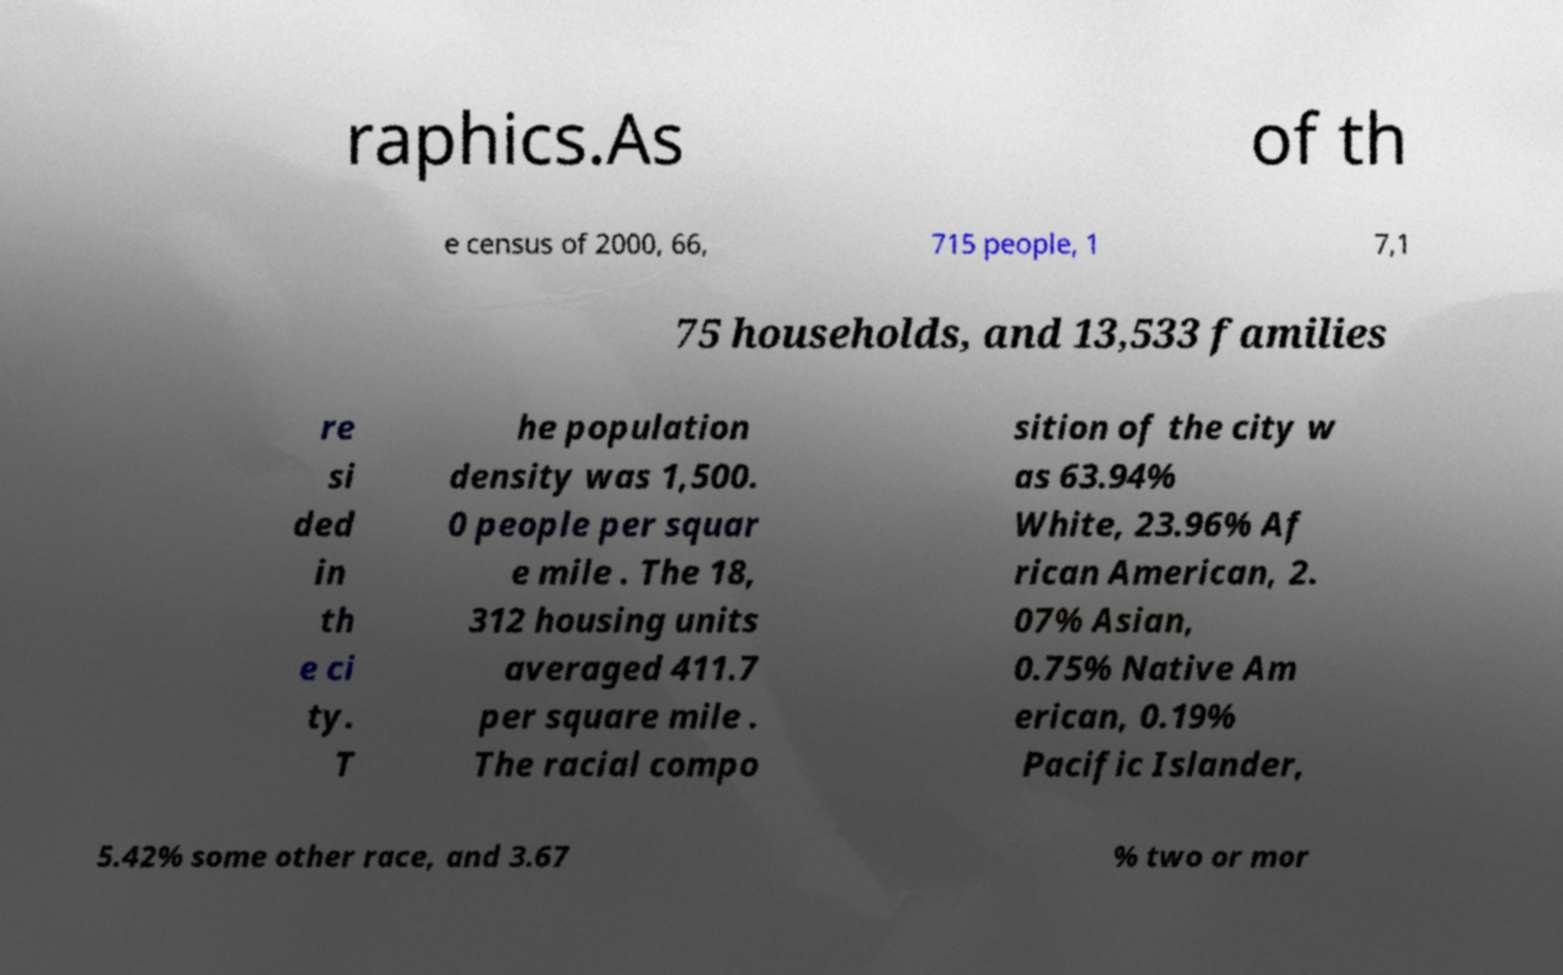There's text embedded in this image that I need extracted. Can you transcribe it verbatim? raphics.As of th e census of 2000, 66, 715 people, 1 7,1 75 households, and 13,533 families re si ded in th e ci ty. T he population density was 1,500. 0 people per squar e mile . The 18, 312 housing units averaged 411.7 per square mile . The racial compo sition of the city w as 63.94% White, 23.96% Af rican American, 2. 07% Asian, 0.75% Native Am erican, 0.19% Pacific Islander, 5.42% some other race, and 3.67 % two or mor 